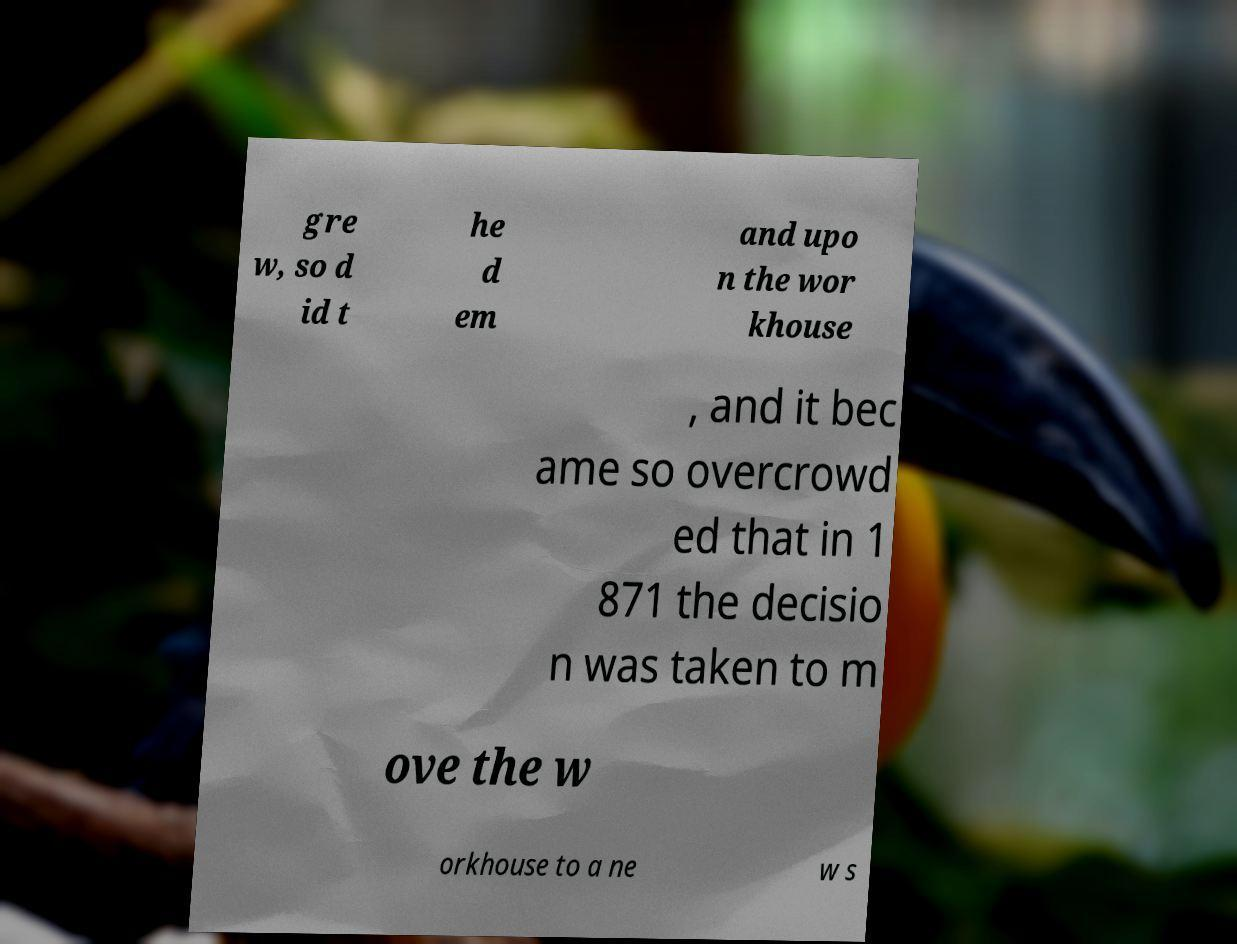Could you assist in decoding the text presented in this image and type it out clearly? gre w, so d id t he d em and upo n the wor khouse , and it bec ame so overcrowd ed that in 1 871 the decisio n was taken to m ove the w orkhouse to a ne w s 